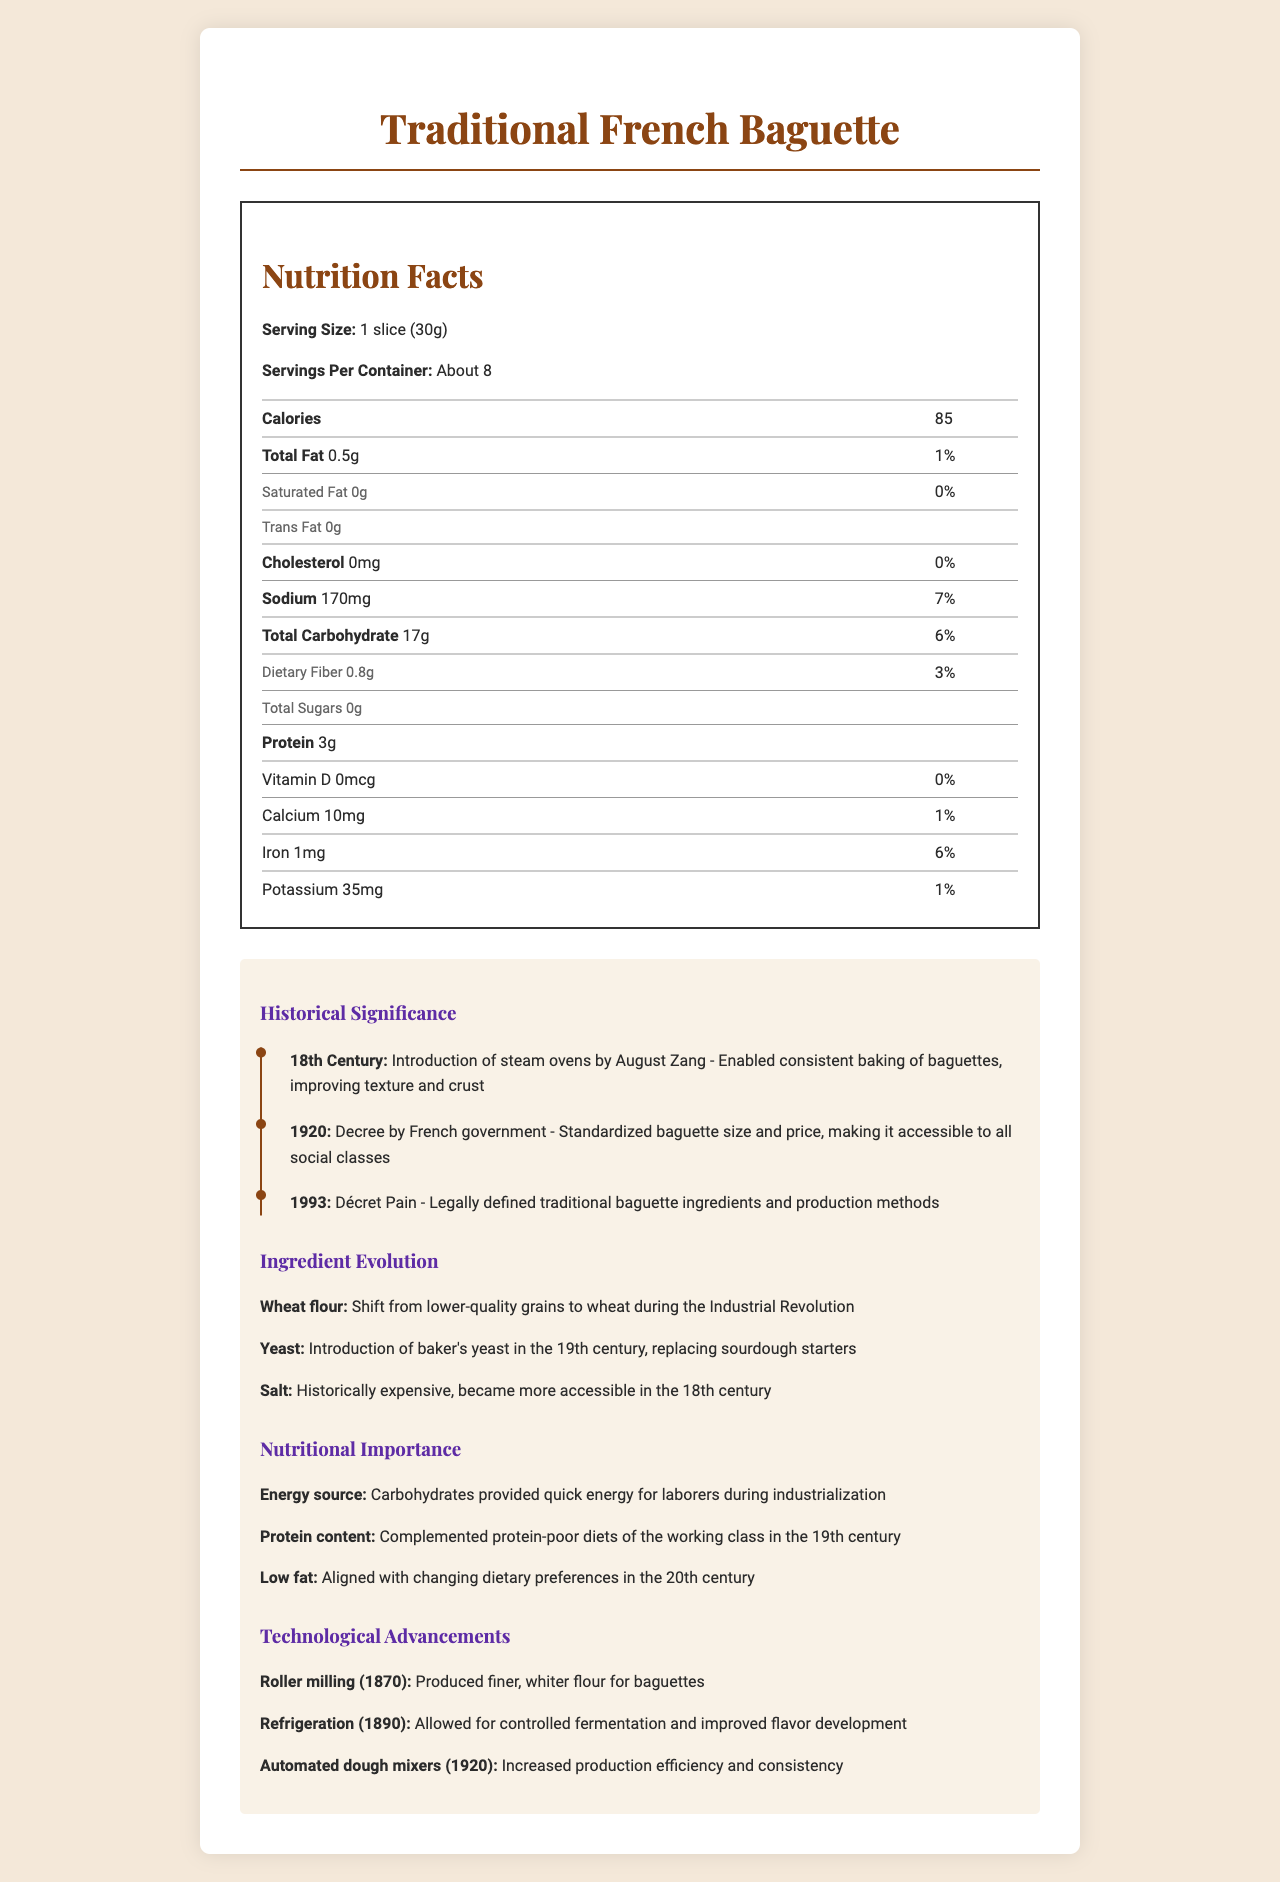what is the serving size of the Traditional French Baguette? The document explicitly provides the serving size as "1 slice (30g)" under the Nutrition Facts section.
Answer: 1 slice (30g) How many calories are in one serving? According to the nutrition facts, there are 85 calories per serving.
Answer: 85 What is the percentage of daily value for sodium per serving? The document states that the sodium content per serving amounts to 7% of the daily value.
Answer: 7% What are the two main technological advancements in the 19th century related to baguette production? The document lists roller milling in 1870 and refrigeration in 1890 as significant technological advancements.
Answer: Roller milling and Refrigeration Describe the historical significance of the Decree by the French government in 1920 for the baguette. The document explains that the 1920 decree by the French government standardized the size and price of the baguette.
Answer: Standardized baguette size and price, making it accessible to all social classes Which ingredient's historical context involves a shift from lower-quality grains to wheat during the Industrial Revolution? A. Yeast B. Salt C. Wheat flour D. Water The document specifically mentions that wheat flour's historical context involved a shift to higher quality during the Industrial Revolution.
Answer: C. Wheat flour Which technological advancement allowed for controlled fermentation and improved flavor development in baguette production? A. Roller milling B. Steam ovens C. Refrigeration D. Automated dough mixers The document states that refrigeration, introduced in 1890, allowed for controlled fermentation and improved flavor development.
Answer: C. Refrigeration Can the total daily value of protein be found in the document? While the document lists the amount of protein per serving (3g), it does not provide a percentage daily value for protein.
Answer: No Does a traditional French baguette contain any trans fat? The document indicates that the amount of trans fat in a serving is 0g.
Answer: No Summarize the main idea of the document. The document not only gives nutritional facts but also contextualizes the bread's historical, technological, and nutritional evolution.
Answer: The document provides detailed nutritional information for a traditional French baguette, including its serving size, calories, and various nutrient amounts. It also delves into the historical significance, ingredient evolution, nutritional importance, and technological advancements that have influenced the development and production of the baguette over time. What is the impact of the introduction of steam ovens by August Zang in the 18th century? The document specifically details that steam ovens, introduced by August Zang, allowed for consistent baking, which enhanced the baguette's texture and crust.
Answer: Enabled consistent baking of baguettes, improving texture and crust When was the Décret Pain established, and what did it achieve? The document states that the Décret Pain was established in 1993 and set legal definitions for traditional baguette ingredients and production methodologies.
Answer: 1993; Legally defined traditional baguette ingredients and production methods Provide an example of how the nutritional content of the baguette catered to the laborers during industrialization. The document notes that carbohydrates in the baguette offered a quick energy source, beneficial for the laborers during industrialization.
Answer: Carbohydrates provided quick energy for laborers How many grams of dietary fiber are in one serving of the baguette? The nutrition label lists 0.8g of dietary fiber per serving.
Answer: 0.8g Is there enough information to determine the potassium's percentage daily value per serving? The document indicates that the potassium content per serving is 1% of the daily value.
Answer: Yes What was the driving factor for the ingredient evolution involving yeast in the 19th century? The document explains that baker's yeast was introduced in the 19th century, which replaced sourdough starters in bread-making.
Answer: Introduction of baker's yeast, replacing sourdough starters 